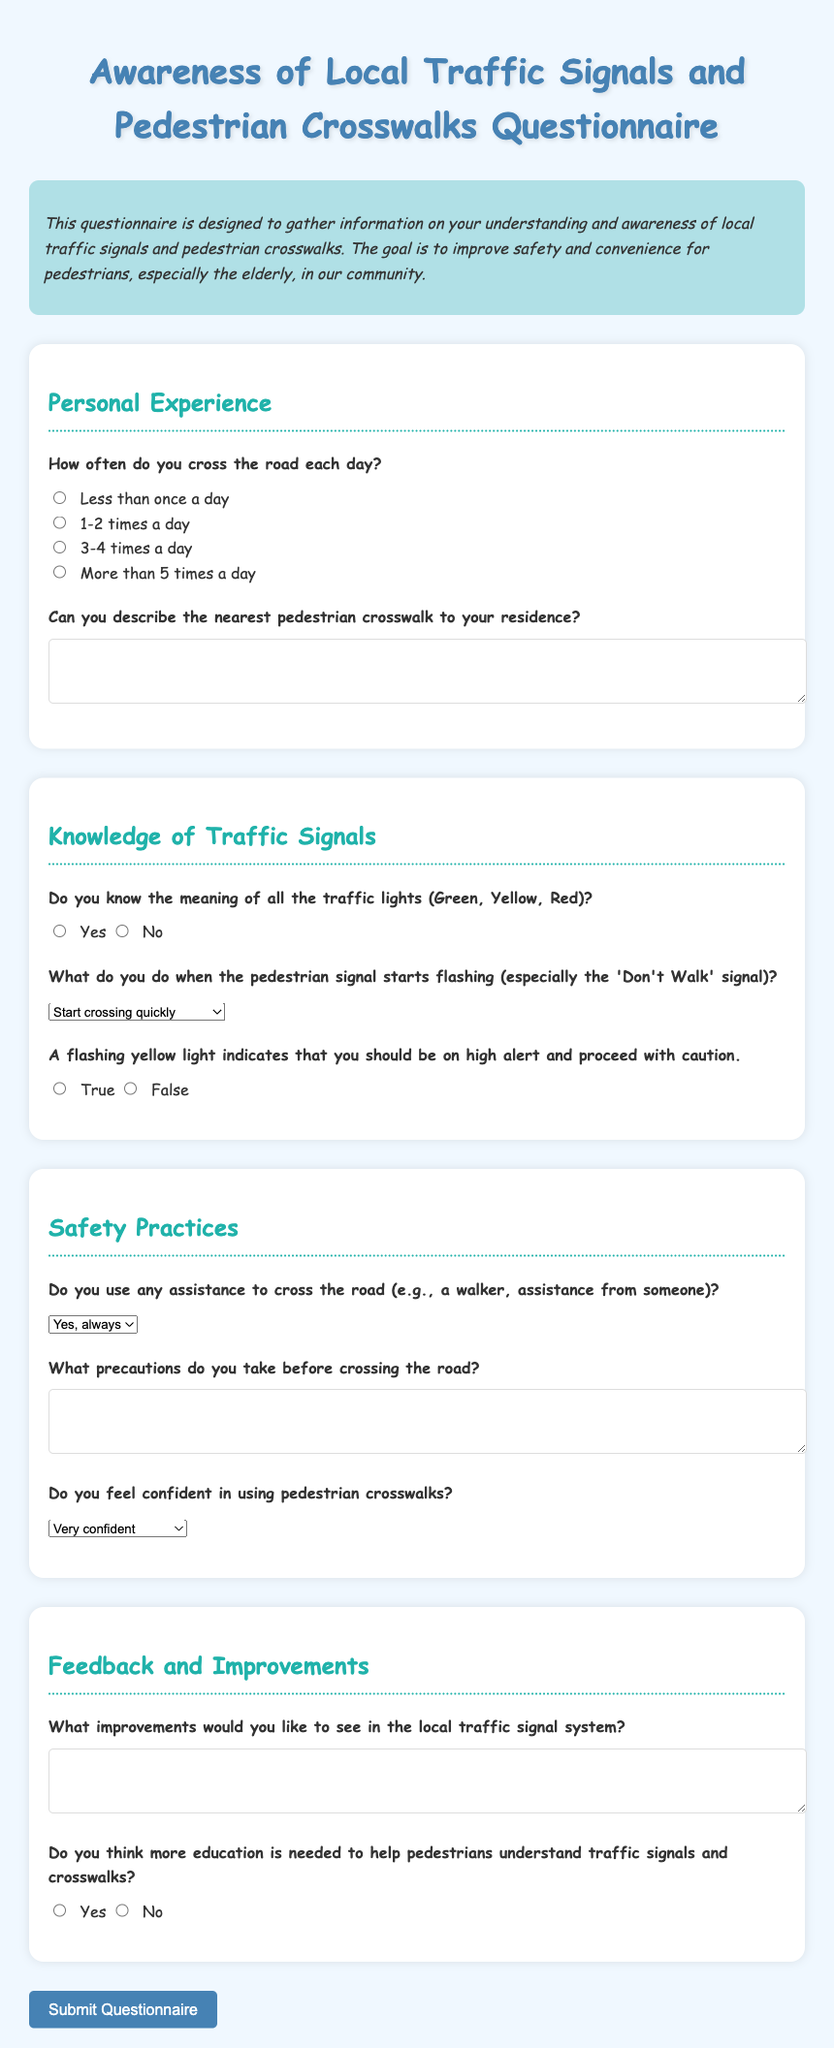What is the title of the questionnaire? The title of the questionnaire is stated at the beginning of the document.
Answer: Awareness of Local Traffic Signals and Pedestrian Crosswalks Questionnaire How often does the questionnaire ask about crossing the road? The document includes a specific question regarding the frequency of crossing the road each day.
Answer: Daily What options are provided for describing the nearest pedestrian crosswalk? The questionnaire includes a text area for respondents to describe their crosswalk, providing no predefined options.
Answer: Open-ended description What does a flashing yellow light indicate according to the document? The questionnaire poses a true or false question regarding the indication of a flashing yellow light.
Answer: High alert and proceed with caution In what section is the question about improvements for the local traffic signal system? The question regarding improvements is asked in the feedback and improvements section of the document.
Answer: Feedback and Improvements How many times a day can one choose as the maximum frequency of crossing? The questionnaire provides options for crossing frequency, with one option being over five times.
Answer: More than 5 times a day What type of assistance is mentioned for crossing the road? The document asks if respondents use assistance such as a walker or help from others, indicating a focus on safety.
Answer: Walker or assistance Is there a question about confidence in using pedestrian crosswalks? The questionnaire includes a specific question regarding the respondents' confidence level when using crosswalks.
Answer: Yes, there is a question 